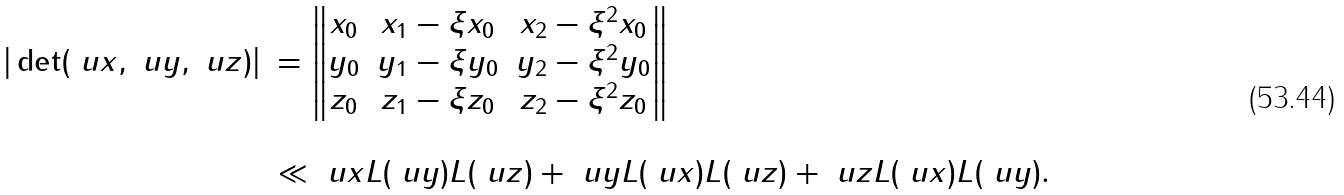<formula> <loc_0><loc_0><loc_500><loc_500>\begin{array} { r l } | \det ( \ u x , \ u y , \ u z ) | & = \left \| \begin{matrix} x _ { 0 } & x _ { 1 } - \xi x _ { 0 } & x _ { 2 } - \xi ^ { 2 } x _ { 0 } \\ y _ { 0 } & y _ { 1 } - \xi y _ { 0 } & y _ { 2 } - \xi ^ { 2 } y _ { 0 } \\ z _ { 0 } & z _ { 1 } - \xi z _ { 0 } & z _ { 2 } - \xi ^ { 2 } z _ { 0 } \\ \end{matrix} \right \| \\ \\ & \ll \| \ u x \| L ( \ u y ) L ( \ u z ) + \| \ u y \| L ( \ u x ) L ( \ u z ) + \| \ u z \| L ( \ u x ) L ( \ u y ) . \\ \end{array}</formula> 